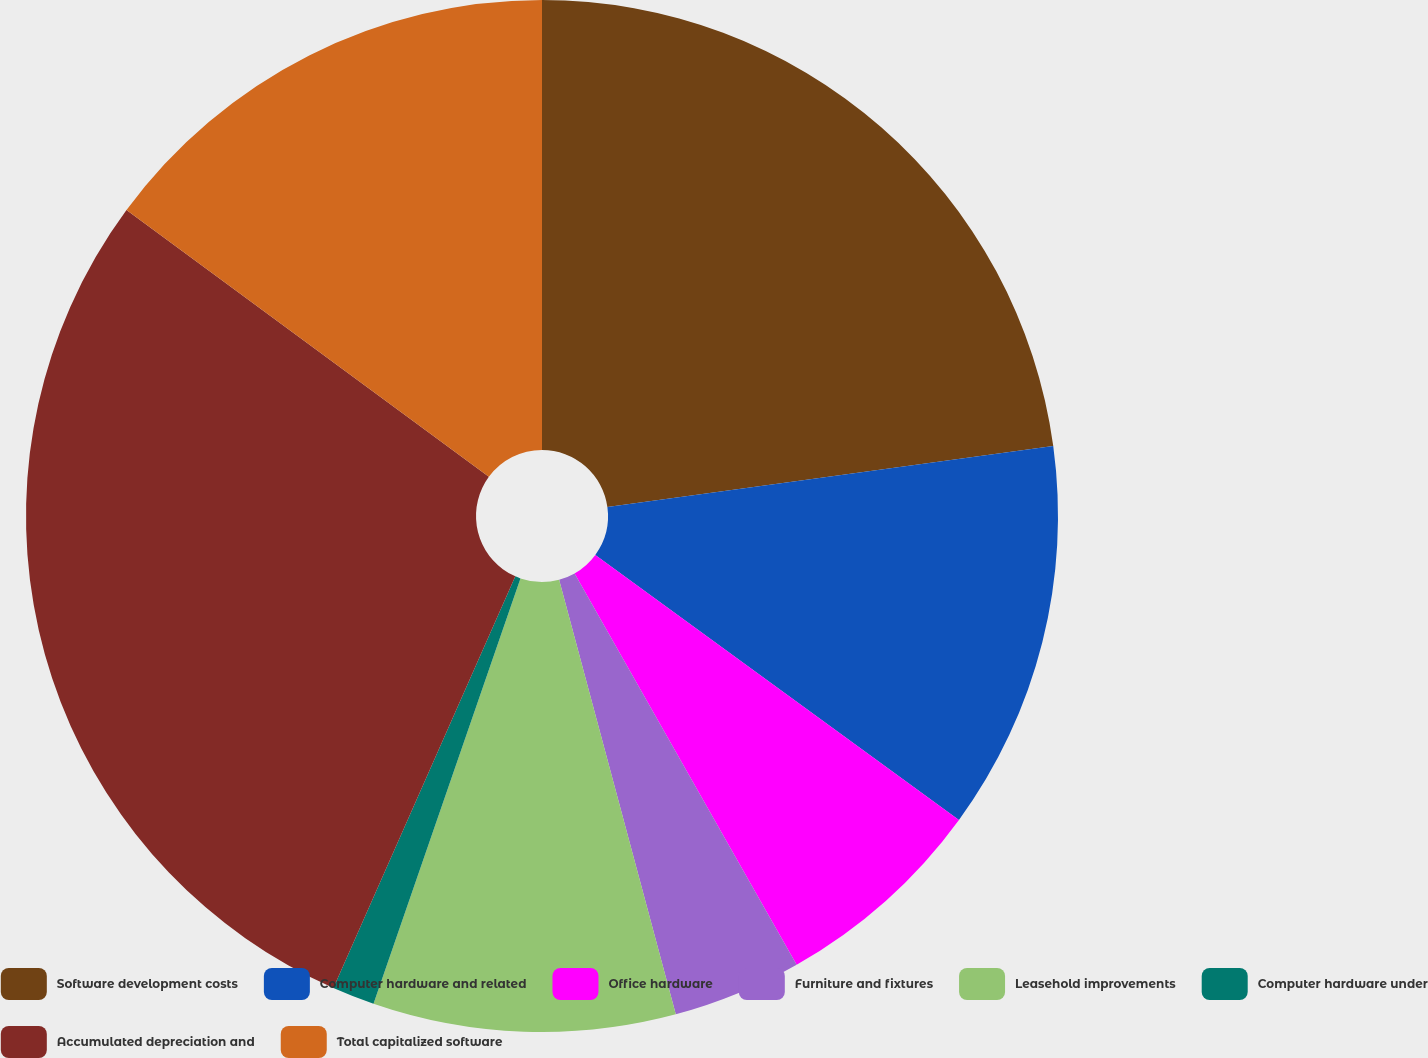Convert chart. <chart><loc_0><loc_0><loc_500><loc_500><pie_chart><fcel>Software development costs<fcel>Computer hardware and related<fcel>Office hardware<fcel>Furniture and fixtures<fcel>Leasehold improvements<fcel>Computer hardware under<fcel>Accumulated depreciation and<fcel>Total capitalized software<nl><fcel>22.84%<fcel>12.19%<fcel>6.76%<fcel>4.04%<fcel>9.47%<fcel>1.33%<fcel>28.48%<fcel>14.9%<nl></chart> 